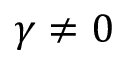Convert formula to latex. <formula><loc_0><loc_0><loc_500><loc_500>\gamma \neq 0</formula> 